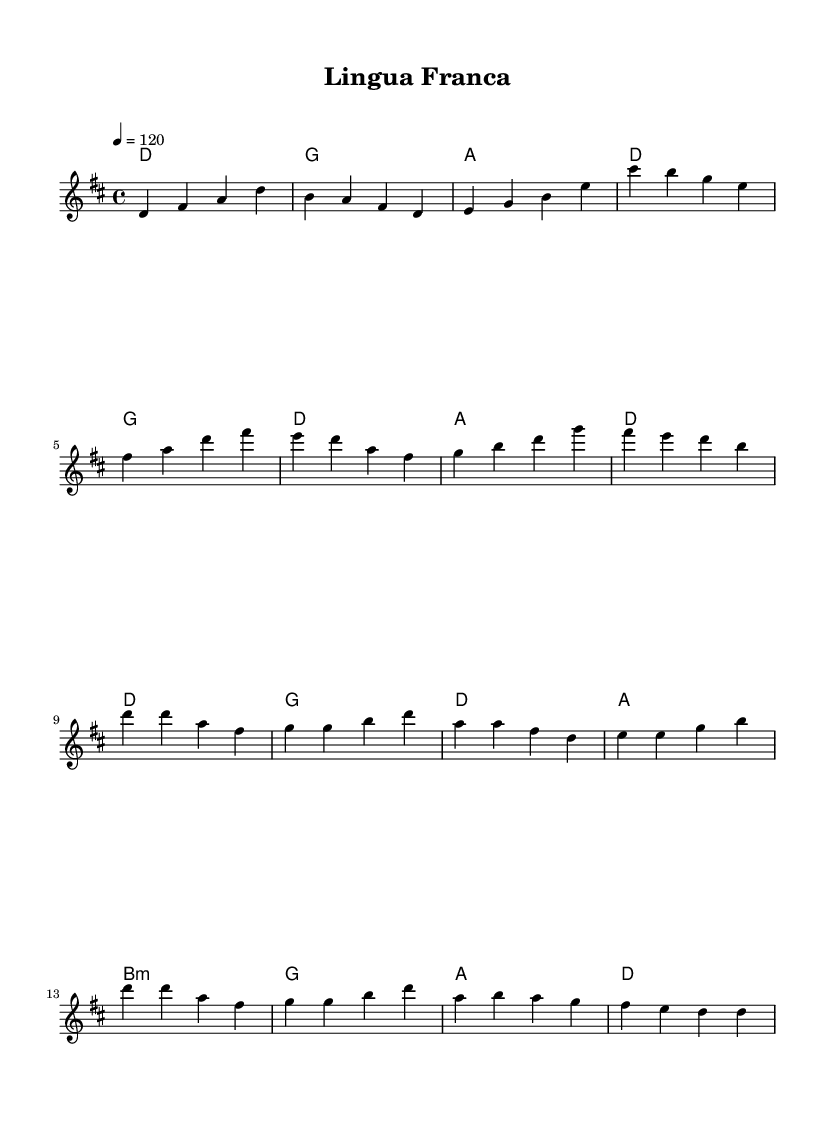What is the key signature of this music? The key signature indicated in the score is D major, which has two sharps (F# and C#).
Answer: D major What is the time signature of this music? The time signature shown in the score is 4/4, meaning there are four beats in each measure and the quarter note gets one beat.
Answer: 4/4 What is the tempo marking of this music? The tempo marking specified in the score is 120 beats per minute, indicating the speed for performing the piece at a moderate pace.
Answer: 120 How many measures are in the verse section? By counting the measures presented in the melody section, there are eight measures in the verse part of the music.
Answer: 8 What is the first chord of the chorus? The first chord in the chorus, as shown in the harmonies, is D major.
Answer: D What lyrics are associated with the chorus of the song? The lyrics associated directly with the chorus highlight the themes of connection and cultural exchange, specifically mentioning "Lingua franca" and "Pidgin, creole."
Answer: Lingua franca, bridge between worlds How do the verses and chorus differ in terms of structure? The verses consist of eight measures with varied melodic lines, while the chorus is more repetitive and comprises a similar rhythmic structure, reinforcing the main theme.
Answer: Structure difference 